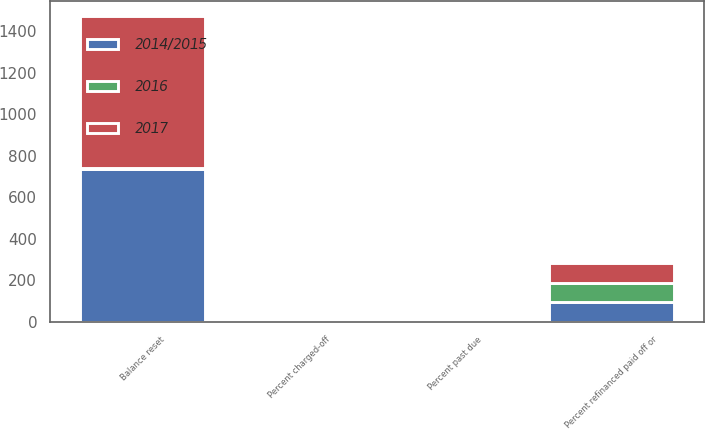Convert chart to OTSL. <chart><loc_0><loc_0><loc_500><loc_500><stacked_bar_chart><ecel><fcel>Balance reset<fcel>Percent refinanced paid off or<fcel>Percent past due<fcel>Percent charged-off<nl><fcel>2016<fcel>4<fcel>93<fcel>3<fcel>4<nl><fcel>2014/2015<fcel>738<fcel>95<fcel>3<fcel>2<nl><fcel>2017<fcel>730<fcel>94<fcel>4<fcel>2<nl></chart> 